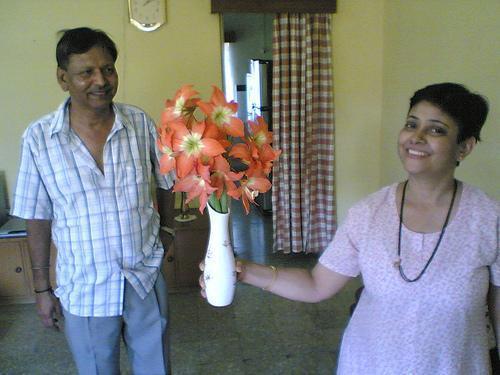How many people are in the picture?
Give a very brief answer. 2. How many sandwiches with orange paste are in the picture?
Give a very brief answer. 0. 